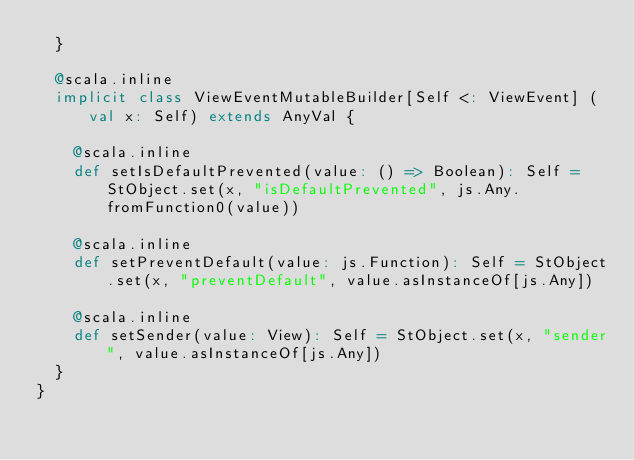Convert code to text. <code><loc_0><loc_0><loc_500><loc_500><_Scala_>  }
  
  @scala.inline
  implicit class ViewEventMutableBuilder[Self <: ViewEvent] (val x: Self) extends AnyVal {
    
    @scala.inline
    def setIsDefaultPrevented(value: () => Boolean): Self = StObject.set(x, "isDefaultPrevented", js.Any.fromFunction0(value))
    
    @scala.inline
    def setPreventDefault(value: js.Function): Self = StObject.set(x, "preventDefault", value.asInstanceOf[js.Any])
    
    @scala.inline
    def setSender(value: View): Self = StObject.set(x, "sender", value.asInstanceOf[js.Any])
  }
}
</code> 